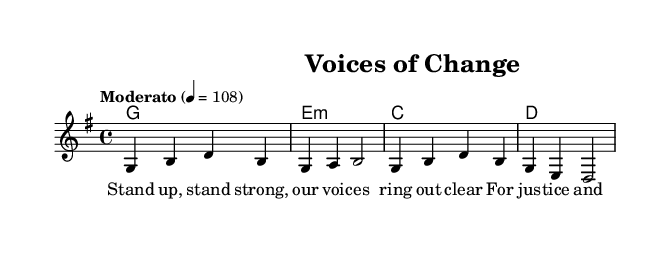What is the key signature of this music? The key signature is G major, which has one sharp (F#). This can be identified by looking at the beginning of the staff where the sharp is indicated.
Answer: G major What is the time signature of this music? The time signature is 4/4, which denotes four beats per measure with a quarter note receiving one beat. This information is located at the beginning of the sheet music after the key signature.
Answer: 4/4 What is the tempo marking for this piece? The tempo marking is "Moderato," which indicates a moderate speed. This marking is commonly found above the staff right after the time signature.
Answer: Moderato How many measures are in the melody section? There are four measures in the melody section, as we can count the vertical lines that separate the measures in the staff. Each segment between the bar lines represents one measure.
Answer: 4 What is the first chord played in this piece? The first chord is G major, which is indicated at the beginning of the chord progression in the chord names section of the sheet music.
Answer: G Which lyrical theme is reflected in the verse? The lyrical theme focuses on justice and equality, as expressed in the lyrics "For justice and equality, we'll persevere." This can be understood by reading the lyrics underneath the melody line.
Answer: Justice and equality What style of music does this piece represent? This piece represents Folk music, characterized by its emphasis on social themes and collective experiences. Folk music from this era typically highlighted issues like labor movements and civil rights, which is evident in the lyrics and the overall style.
Answer: Folk 